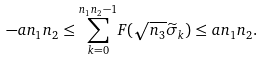<formula> <loc_0><loc_0><loc_500><loc_500>- a n _ { 1 } n _ { 2 } \leq \overset { n _ { 1 } n _ { 2 } - 1 } { \underset { k = 0 } \sum } F ( \sqrt { n _ { 3 } } \widetilde { \sigma } _ { k } ) \leq a n _ { 1 } n _ { 2 } .</formula> 